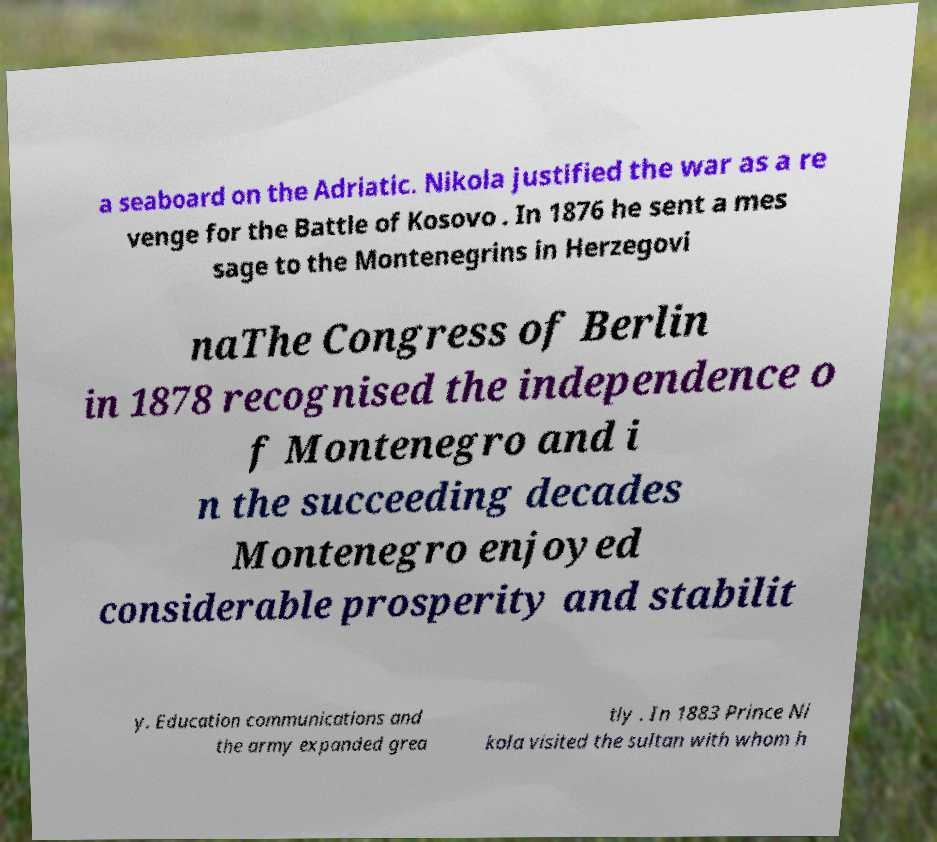Could you extract and type out the text from this image? a seaboard on the Adriatic. Nikola justified the war as a re venge for the Battle of Kosovo . In 1876 he sent a mes sage to the Montenegrins in Herzegovi naThe Congress of Berlin in 1878 recognised the independence o f Montenegro and i n the succeeding decades Montenegro enjoyed considerable prosperity and stabilit y. Education communications and the army expanded grea tly . In 1883 Prince Ni kola visited the sultan with whom h 